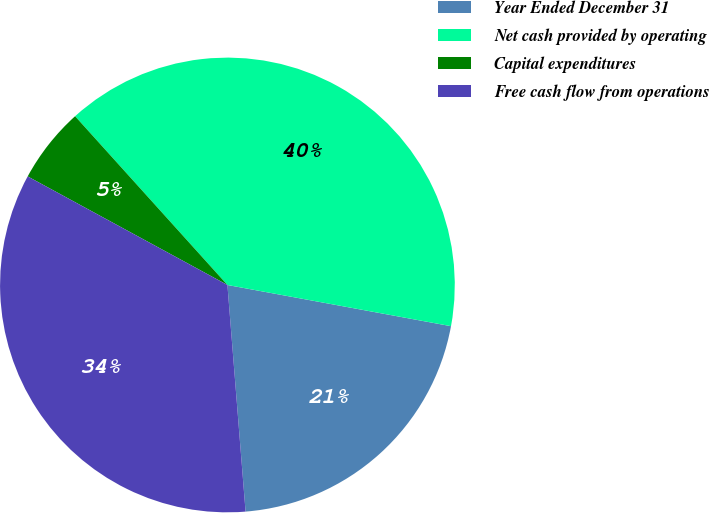Convert chart to OTSL. <chart><loc_0><loc_0><loc_500><loc_500><pie_chart><fcel>Year Ended December 31<fcel>Net cash provided by operating<fcel>Capital expenditures<fcel>Free cash flow from operations<nl><fcel>20.83%<fcel>39.59%<fcel>5.39%<fcel>34.2%<nl></chart> 